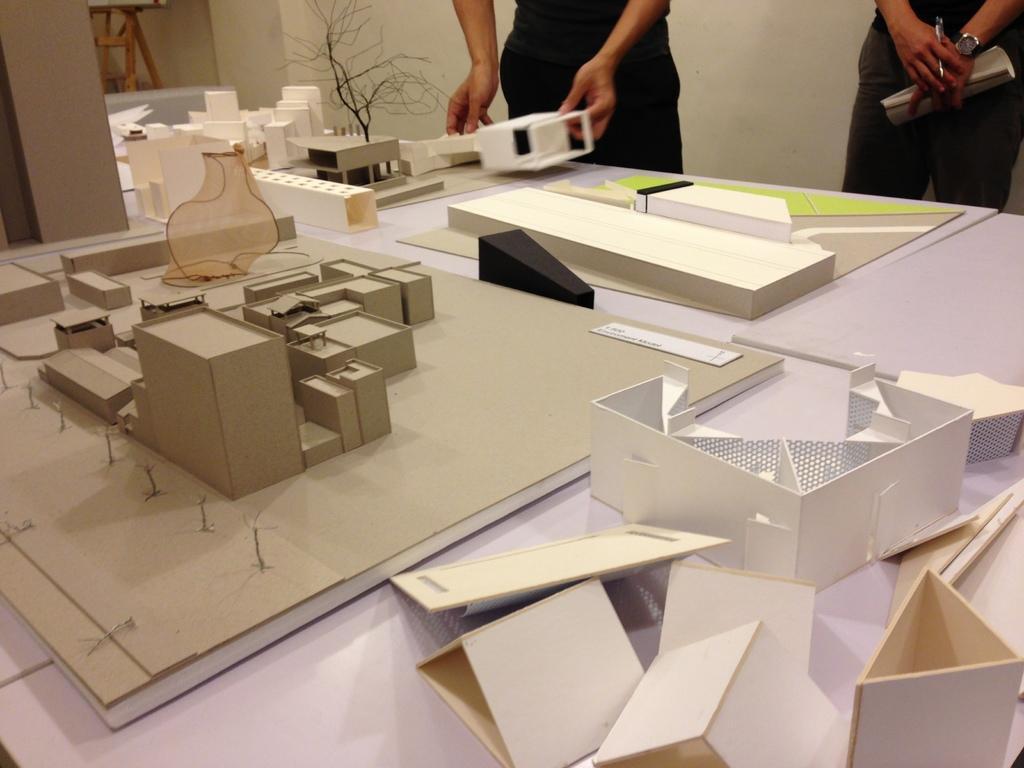How would you summarize this image in a sentence or two? There is a table with cardboard homes placed on it and man standing beside table and another man standing beside the table holding a book , a watch to his left hand and pen in his right hand. 